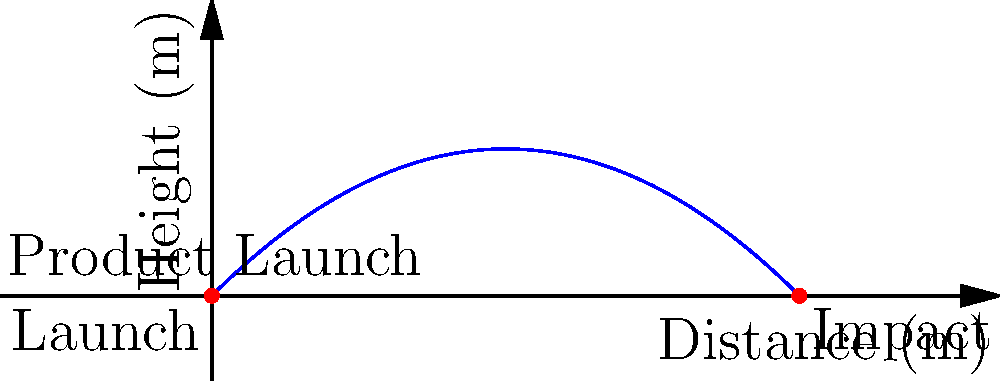In a new product launch advertisement, you want to use a projectile motion to symbolize the product's trajectory in the market. If the initial velocity of the projectile is 50 m/s at a 45-degree angle, what is the total horizontal distance covered by the projectile before it returns to its initial height? Assume g = 9.8 m/s². To solve this problem, we'll use the equations of projectile motion:

1) First, we need to find the time of flight. For a projectile launched from and returning to the same height:
   
   $t_{flight} = \frac{2v_0\sin\theta}{g}$

   Where $v_0$ is the initial velocity, $\theta$ is the launch angle, and $g$ is the acceleration due to gravity.

2) Substituting the given values:
   
   $t_{flight} = \frac{2 \cdot 50 \cdot \sin(45°)}{9.8} \approx 7.22$ seconds

3) Now, to find the horizontal distance, we use:
   
   $d = v_0\cos\theta \cdot t_{flight}$

4) Substituting the values:
   
   $d = 50 \cdot \cos(45°) \cdot 7.22$

5) Simplify:
   
   $d = 50 \cdot \frac{\sqrt{2}}{2} \cdot 7.22 \approx 255.56$ meters

Therefore, the total horizontal distance covered by the projectile is approximately 255.56 meters.
Answer: 255.56 meters 